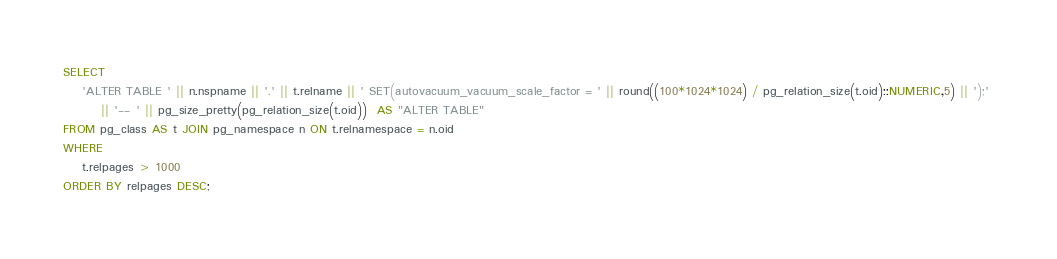Convert code to text. <code><loc_0><loc_0><loc_500><loc_500><_SQL_>SELECT
    'ALTER TABLE ' || n.nspname || '.' || t.relname || ' SET(autovacuum_vacuum_scale_factor = ' || round((100*1024*1024) / pg_relation_size(t.oid)::NUMERIC,5) || ');' 
        || '-- ' || pg_size_pretty(pg_relation_size(t.oid))  AS "ALTER TABLE"
FROM pg_class AS t JOIN pg_namespace n ON t.relnamespace = n.oid
WHERE
    t.relpages > 1000
ORDER BY relpages DESC;</code> 